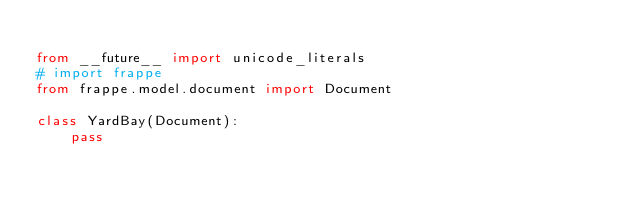Convert code to text. <code><loc_0><loc_0><loc_500><loc_500><_Python_>
from __future__ import unicode_literals
# import frappe
from frappe.model.document import Document

class YardBay(Document):
	pass
</code> 